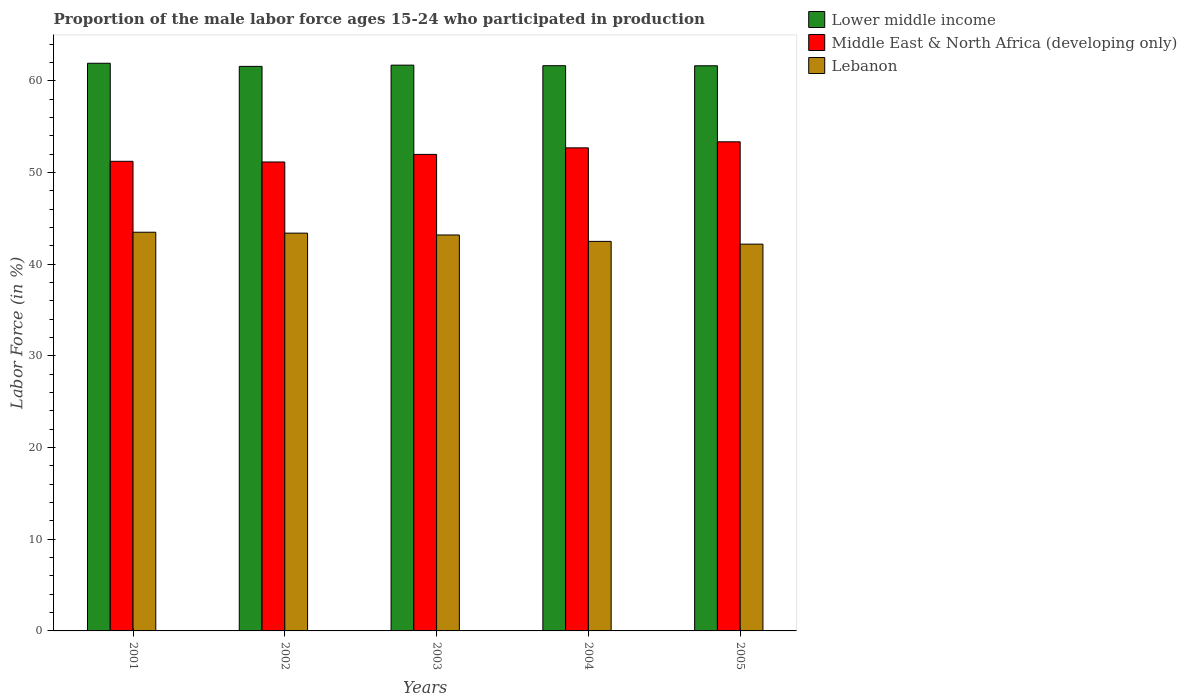Are the number of bars per tick equal to the number of legend labels?
Your response must be concise. Yes. Are the number of bars on each tick of the X-axis equal?
Your response must be concise. Yes. How many bars are there on the 2nd tick from the left?
Keep it short and to the point. 3. What is the proportion of the male labor force who participated in production in Middle East & North Africa (developing only) in 2002?
Offer a very short reply. 51.16. Across all years, what is the maximum proportion of the male labor force who participated in production in Lower middle income?
Give a very brief answer. 61.93. Across all years, what is the minimum proportion of the male labor force who participated in production in Lebanon?
Ensure brevity in your answer.  42.2. What is the total proportion of the male labor force who participated in production in Lower middle income in the graph?
Offer a terse response. 308.58. What is the difference between the proportion of the male labor force who participated in production in Lebanon in 2002 and that in 2003?
Offer a terse response. 0.2. What is the difference between the proportion of the male labor force who participated in production in Lower middle income in 2003 and the proportion of the male labor force who participated in production in Lebanon in 2002?
Provide a succinct answer. 18.33. What is the average proportion of the male labor force who participated in production in Lower middle income per year?
Your answer should be compact. 61.72. In the year 2001, what is the difference between the proportion of the male labor force who participated in production in Lebanon and proportion of the male labor force who participated in production in Middle East & North Africa (developing only)?
Keep it short and to the point. -7.74. In how many years, is the proportion of the male labor force who participated in production in Lower middle income greater than 34 %?
Your response must be concise. 5. What is the ratio of the proportion of the male labor force who participated in production in Lower middle income in 2003 to that in 2004?
Offer a very short reply. 1. Is the proportion of the male labor force who participated in production in Lower middle income in 2003 less than that in 2005?
Offer a very short reply. No. Is the difference between the proportion of the male labor force who participated in production in Lebanon in 2002 and 2005 greater than the difference between the proportion of the male labor force who participated in production in Middle East & North Africa (developing only) in 2002 and 2005?
Ensure brevity in your answer.  Yes. What is the difference between the highest and the second highest proportion of the male labor force who participated in production in Middle East & North Africa (developing only)?
Provide a short and direct response. 0.66. What is the difference between the highest and the lowest proportion of the male labor force who participated in production in Lower middle income?
Provide a succinct answer. 0.34. In how many years, is the proportion of the male labor force who participated in production in Lebanon greater than the average proportion of the male labor force who participated in production in Lebanon taken over all years?
Ensure brevity in your answer.  3. Is the sum of the proportion of the male labor force who participated in production in Lebanon in 2003 and 2004 greater than the maximum proportion of the male labor force who participated in production in Lower middle income across all years?
Offer a very short reply. Yes. What does the 3rd bar from the left in 2005 represents?
Provide a succinct answer. Lebanon. What does the 2nd bar from the right in 2003 represents?
Your answer should be compact. Middle East & North Africa (developing only). Is it the case that in every year, the sum of the proportion of the male labor force who participated in production in Lower middle income and proportion of the male labor force who participated in production in Lebanon is greater than the proportion of the male labor force who participated in production in Middle East & North Africa (developing only)?
Ensure brevity in your answer.  Yes. How many years are there in the graph?
Your answer should be very brief. 5. What is the difference between two consecutive major ticks on the Y-axis?
Make the answer very short. 10. Where does the legend appear in the graph?
Ensure brevity in your answer.  Top right. How many legend labels are there?
Make the answer very short. 3. What is the title of the graph?
Offer a very short reply. Proportion of the male labor force ages 15-24 who participated in production. What is the label or title of the X-axis?
Ensure brevity in your answer.  Years. What is the label or title of the Y-axis?
Your answer should be compact. Labor Force (in %). What is the Labor Force (in %) of Lower middle income in 2001?
Keep it short and to the point. 61.93. What is the Labor Force (in %) in Middle East & North Africa (developing only) in 2001?
Provide a short and direct response. 51.24. What is the Labor Force (in %) of Lebanon in 2001?
Provide a succinct answer. 43.5. What is the Labor Force (in %) of Lower middle income in 2002?
Your answer should be very brief. 61.59. What is the Labor Force (in %) in Middle East & North Africa (developing only) in 2002?
Offer a terse response. 51.16. What is the Labor Force (in %) in Lebanon in 2002?
Provide a succinct answer. 43.4. What is the Labor Force (in %) of Lower middle income in 2003?
Keep it short and to the point. 61.73. What is the Labor Force (in %) in Middle East & North Africa (developing only) in 2003?
Offer a very short reply. 51.99. What is the Labor Force (in %) in Lebanon in 2003?
Your answer should be very brief. 43.2. What is the Labor Force (in %) of Lower middle income in 2004?
Keep it short and to the point. 61.67. What is the Labor Force (in %) of Middle East & North Africa (developing only) in 2004?
Provide a succinct answer. 52.71. What is the Labor Force (in %) of Lebanon in 2004?
Make the answer very short. 42.5. What is the Labor Force (in %) in Lower middle income in 2005?
Ensure brevity in your answer.  61.66. What is the Labor Force (in %) of Middle East & North Africa (developing only) in 2005?
Your answer should be compact. 53.37. What is the Labor Force (in %) of Lebanon in 2005?
Your answer should be compact. 42.2. Across all years, what is the maximum Labor Force (in %) of Lower middle income?
Provide a succinct answer. 61.93. Across all years, what is the maximum Labor Force (in %) of Middle East & North Africa (developing only)?
Make the answer very short. 53.37. Across all years, what is the maximum Labor Force (in %) in Lebanon?
Offer a terse response. 43.5. Across all years, what is the minimum Labor Force (in %) in Lower middle income?
Your answer should be very brief. 61.59. Across all years, what is the minimum Labor Force (in %) of Middle East & North Africa (developing only)?
Keep it short and to the point. 51.16. Across all years, what is the minimum Labor Force (in %) in Lebanon?
Your answer should be compact. 42.2. What is the total Labor Force (in %) of Lower middle income in the graph?
Give a very brief answer. 308.58. What is the total Labor Force (in %) of Middle East & North Africa (developing only) in the graph?
Your answer should be very brief. 260.46. What is the total Labor Force (in %) in Lebanon in the graph?
Provide a short and direct response. 214.8. What is the difference between the Labor Force (in %) in Lower middle income in 2001 and that in 2002?
Provide a short and direct response. 0.34. What is the difference between the Labor Force (in %) of Middle East & North Africa (developing only) in 2001 and that in 2002?
Provide a short and direct response. 0.07. What is the difference between the Labor Force (in %) of Lebanon in 2001 and that in 2002?
Keep it short and to the point. 0.1. What is the difference between the Labor Force (in %) in Lower middle income in 2001 and that in 2003?
Give a very brief answer. 0.21. What is the difference between the Labor Force (in %) in Middle East & North Africa (developing only) in 2001 and that in 2003?
Keep it short and to the point. -0.75. What is the difference between the Labor Force (in %) of Lebanon in 2001 and that in 2003?
Your answer should be very brief. 0.3. What is the difference between the Labor Force (in %) of Lower middle income in 2001 and that in 2004?
Offer a very short reply. 0.27. What is the difference between the Labor Force (in %) of Middle East & North Africa (developing only) in 2001 and that in 2004?
Keep it short and to the point. -1.47. What is the difference between the Labor Force (in %) of Lower middle income in 2001 and that in 2005?
Provide a succinct answer. 0.27. What is the difference between the Labor Force (in %) in Middle East & North Africa (developing only) in 2001 and that in 2005?
Your answer should be compact. -2.13. What is the difference between the Labor Force (in %) in Lower middle income in 2002 and that in 2003?
Keep it short and to the point. -0.13. What is the difference between the Labor Force (in %) in Middle East & North Africa (developing only) in 2002 and that in 2003?
Your response must be concise. -0.83. What is the difference between the Labor Force (in %) in Lebanon in 2002 and that in 2003?
Offer a very short reply. 0.2. What is the difference between the Labor Force (in %) of Lower middle income in 2002 and that in 2004?
Make the answer very short. -0.07. What is the difference between the Labor Force (in %) of Middle East & North Africa (developing only) in 2002 and that in 2004?
Ensure brevity in your answer.  -1.54. What is the difference between the Labor Force (in %) of Lebanon in 2002 and that in 2004?
Your answer should be compact. 0.9. What is the difference between the Labor Force (in %) of Lower middle income in 2002 and that in 2005?
Your answer should be very brief. -0.07. What is the difference between the Labor Force (in %) of Middle East & North Africa (developing only) in 2002 and that in 2005?
Offer a very short reply. -2.2. What is the difference between the Labor Force (in %) of Lebanon in 2002 and that in 2005?
Provide a succinct answer. 1.2. What is the difference between the Labor Force (in %) of Lower middle income in 2003 and that in 2004?
Offer a very short reply. 0.06. What is the difference between the Labor Force (in %) in Middle East & North Africa (developing only) in 2003 and that in 2004?
Make the answer very short. -0.72. What is the difference between the Labor Force (in %) in Lebanon in 2003 and that in 2004?
Make the answer very short. 0.7. What is the difference between the Labor Force (in %) in Lower middle income in 2003 and that in 2005?
Provide a short and direct response. 0.07. What is the difference between the Labor Force (in %) in Middle East & North Africa (developing only) in 2003 and that in 2005?
Make the answer very short. -1.37. What is the difference between the Labor Force (in %) of Lebanon in 2003 and that in 2005?
Your answer should be very brief. 1. What is the difference between the Labor Force (in %) in Lower middle income in 2004 and that in 2005?
Make the answer very short. 0.01. What is the difference between the Labor Force (in %) in Middle East & North Africa (developing only) in 2004 and that in 2005?
Your response must be concise. -0.66. What is the difference between the Labor Force (in %) of Lower middle income in 2001 and the Labor Force (in %) of Middle East & North Africa (developing only) in 2002?
Ensure brevity in your answer.  10.77. What is the difference between the Labor Force (in %) of Lower middle income in 2001 and the Labor Force (in %) of Lebanon in 2002?
Your answer should be compact. 18.53. What is the difference between the Labor Force (in %) in Middle East & North Africa (developing only) in 2001 and the Labor Force (in %) in Lebanon in 2002?
Ensure brevity in your answer.  7.84. What is the difference between the Labor Force (in %) in Lower middle income in 2001 and the Labor Force (in %) in Middle East & North Africa (developing only) in 2003?
Ensure brevity in your answer.  9.94. What is the difference between the Labor Force (in %) of Lower middle income in 2001 and the Labor Force (in %) of Lebanon in 2003?
Ensure brevity in your answer.  18.73. What is the difference between the Labor Force (in %) in Middle East & North Africa (developing only) in 2001 and the Labor Force (in %) in Lebanon in 2003?
Ensure brevity in your answer.  8.04. What is the difference between the Labor Force (in %) in Lower middle income in 2001 and the Labor Force (in %) in Middle East & North Africa (developing only) in 2004?
Your answer should be compact. 9.23. What is the difference between the Labor Force (in %) in Lower middle income in 2001 and the Labor Force (in %) in Lebanon in 2004?
Your answer should be very brief. 19.43. What is the difference between the Labor Force (in %) in Middle East & North Africa (developing only) in 2001 and the Labor Force (in %) in Lebanon in 2004?
Your answer should be very brief. 8.74. What is the difference between the Labor Force (in %) of Lower middle income in 2001 and the Labor Force (in %) of Middle East & North Africa (developing only) in 2005?
Your answer should be very brief. 8.57. What is the difference between the Labor Force (in %) of Lower middle income in 2001 and the Labor Force (in %) of Lebanon in 2005?
Make the answer very short. 19.73. What is the difference between the Labor Force (in %) in Middle East & North Africa (developing only) in 2001 and the Labor Force (in %) in Lebanon in 2005?
Your response must be concise. 9.04. What is the difference between the Labor Force (in %) of Lower middle income in 2002 and the Labor Force (in %) of Middle East & North Africa (developing only) in 2003?
Provide a succinct answer. 9.6. What is the difference between the Labor Force (in %) in Lower middle income in 2002 and the Labor Force (in %) in Lebanon in 2003?
Your answer should be very brief. 18.39. What is the difference between the Labor Force (in %) in Middle East & North Africa (developing only) in 2002 and the Labor Force (in %) in Lebanon in 2003?
Give a very brief answer. 7.96. What is the difference between the Labor Force (in %) of Lower middle income in 2002 and the Labor Force (in %) of Middle East & North Africa (developing only) in 2004?
Your answer should be very brief. 8.89. What is the difference between the Labor Force (in %) in Lower middle income in 2002 and the Labor Force (in %) in Lebanon in 2004?
Your answer should be compact. 19.09. What is the difference between the Labor Force (in %) in Middle East & North Africa (developing only) in 2002 and the Labor Force (in %) in Lebanon in 2004?
Your response must be concise. 8.66. What is the difference between the Labor Force (in %) in Lower middle income in 2002 and the Labor Force (in %) in Middle East & North Africa (developing only) in 2005?
Keep it short and to the point. 8.23. What is the difference between the Labor Force (in %) of Lower middle income in 2002 and the Labor Force (in %) of Lebanon in 2005?
Ensure brevity in your answer.  19.39. What is the difference between the Labor Force (in %) in Middle East & North Africa (developing only) in 2002 and the Labor Force (in %) in Lebanon in 2005?
Offer a terse response. 8.96. What is the difference between the Labor Force (in %) of Lower middle income in 2003 and the Labor Force (in %) of Middle East & North Africa (developing only) in 2004?
Your response must be concise. 9.02. What is the difference between the Labor Force (in %) of Lower middle income in 2003 and the Labor Force (in %) of Lebanon in 2004?
Offer a very short reply. 19.23. What is the difference between the Labor Force (in %) of Middle East & North Africa (developing only) in 2003 and the Labor Force (in %) of Lebanon in 2004?
Make the answer very short. 9.49. What is the difference between the Labor Force (in %) of Lower middle income in 2003 and the Labor Force (in %) of Middle East & North Africa (developing only) in 2005?
Your answer should be compact. 8.36. What is the difference between the Labor Force (in %) of Lower middle income in 2003 and the Labor Force (in %) of Lebanon in 2005?
Provide a short and direct response. 19.53. What is the difference between the Labor Force (in %) in Middle East & North Africa (developing only) in 2003 and the Labor Force (in %) in Lebanon in 2005?
Your response must be concise. 9.79. What is the difference between the Labor Force (in %) of Lower middle income in 2004 and the Labor Force (in %) of Middle East & North Africa (developing only) in 2005?
Offer a terse response. 8.3. What is the difference between the Labor Force (in %) of Lower middle income in 2004 and the Labor Force (in %) of Lebanon in 2005?
Your answer should be very brief. 19.47. What is the difference between the Labor Force (in %) in Middle East & North Africa (developing only) in 2004 and the Labor Force (in %) in Lebanon in 2005?
Keep it short and to the point. 10.51. What is the average Labor Force (in %) in Lower middle income per year?
Your answer should be very brief. 61.72. What is the average Labor Force (in %) of Middle East & North Africa (developing only) per year?
Give a very brief answer. 52.09. What is the average Labor Force (in %) in Lebanon per year?
Give a very brief answer. 42.96. In the year 2001, what is the difference between the Labor Force (in %) in Lower middle income and Labor Force (in %) in Middle East & North Africa (developing only)?
Offer a terse response. 10.7. In the year 2001, what is the difference between the Labor Force (in %) of Lower middle income and Labor Force (in %) of Lebanon?
Provide a short and direct response. 18.43. In the year 2001, what is the difference between the Labor Force (in %) of Middle East & North Africa (developing only) and Labor Force (in %) of Lebanon?
Make the answer very short. 7.74. In the year 2002, what is the difference between the Labor Force (in %) in Lower middle income and Labor Force (in %) in Middle East & North Africa (developing only)?
Give a very brief answer. 10.43. In the year 2002, what is the difference between the Labor Force (in %) of Lower middle income and Labor Force (in %) of Lebanon?
Provide a succinct answer. 18.19. In the year 2002, what is the difference between the Labor Force (in %) in Middle East & North Africa (developing only) and Labor Force (in %) in Lebanon?
Keep it short and to the point. 7.76. In the year 2003, what is the difference between the Labor Force (in %) of Lower middle income and Labor Force (in %) of Middle East & North Africa (developing only)?
Make the answer very short. 9.74. In the year 2003, what is the difference between the Labor Force (in %) in Lower middle income and Labor Force (in %) in Lebanon?
Your answer should be compact. 18.53. In the year 2003, what is the difference between the Labor Force (in %) in Middle East & North Africa (developing only) and Labor Force (in %) in Lebanon?
Your response must be concise. 8.79. In the year 2004, what is the difference between the Labor Force (in %) in Lower middle income and Labor Force (in %) in Middle East & North Africa (developing only)?
Keep it short and to the point. 8.96. In the year 2004, what is the difference between the Labor Force (in %) of Lower middle income and Labor Force (in %) of Lebanon?
Offer a very short reply. 19.17. In the year 2004, what is the difference between the Labor Force (in %) in Middle East & North Africa (developing only) and Labor Force (in %) in Lebanon?
Your answer should be very brief. 10.21. In the year 2005, what is the difference between the Labor Force (in %) of Lower middle income and Labor Force (in %) of Middle East & North Africa (developing only)?
Your answer should be very brief. 8.3. In the year 2005, what is the difference between the Labor Force (in %) of Lower middle income and Labor Force (in %) of Lebanon?
Offer a terse response. 19.46. In the year 2005, what is the difference between the Labor Force (in %) of Middle East & North Africa (developing only) and Labor Force (in %) of Lebanon?
Make the answer very short. 11.17. What is the ratio of the Labor Force (in %) of Lower middle income in 2001 to that in 2002?
Provide a succinct answer. 1.01. What is the ratio of the Labor Force (in %) in Lower middle income in 2001 to that in 2003?
Offer a very short reply. 1. What is the ratio of the Labor Force (in %) in Middle East & North Africa (developing only) in 2001 to that in 2003?
Your response must be concise. 0.99. What is the ratio of the Labor Force (in %) in Middle East & North Africa (developing only) in 2001 to that in 2004?
Your answer should be very brief. 0.97. What is the ratio of the Labor Force (in %) of Lebanon in 2001 to that in 2004?
Give a very brief answer. 1.02. What is the ratio of the Labor Force (in %) in Lower middle income in 2001 to that in 2005?
Your answer should be compact. 1. What is the ratio of the Labor Force (in %) in Middle East & North Africa (developing only) in 2001 to that in 2005?
Your answer should be compact. 0.96. What is the ratio of the Labor Force (in %) of Lebanon in 2001 to that in 2005?
Keep it short and to the point. 1.03. What is the ratio of the Labor Force (in %) in Middle East & North Africa (developing only) in 2002 to that in 2003?
Keep it short and to the point. 0.98. What is the ratio of the Labor Force (in %) of Lower middle income in 2002 to that in 2004?
Provide a short and direct response. 1. What is the ratio of the Labor Force (in %) in Middle East & North Africa (developing only) in 2002 to that in 2004?
Your answer should be compact. 0.97. What is the ratio of the Labor Force (in %) in Lebanon in 2002 to that in 2004?
Make the answer very short. 1.02. What is the ratio of the Labor Force (in %) of Middle East & North Africa (developing only) in 2002 to that in 2005?
Your response must be concise. 0.96. What is the ratio of the Labor Force (in %) in Lebanon in 2002 to that in 2005?
Offer a very short reply. 1.03. What is the ratio of the Labor Force (in %) in Lower middle income in 2003 to that in 2004?
Offer a very short reply. 1. What is the ratio of the Labor Force (in %) in Middle East & North Africa (developing only) in 2003 to that in 2004?
Your response must be concise. 0.99. What is the ratio of the Labor Force (in %) of Lebanon in 2003 to that in 2004?
Your answer should be very brief. 1.02. What is the ratio of the Labor Force (in %) of Middle East & North Africa (developing only) in 2003 to that in 2005?
Your answer should be very brief. 0.97. What is the ratio of the Labor Force (in %) of Lebanon in 2003 to that in 2005?
Provide a succinct answer. 1.02. What is the ratio of the Labor Force (in %) in Middle East & North Africa (developing only) in 2004 to that in 2005?
Ensure brevity in your answer.  0.99. What is the ratio of the Labor Force (in %) in Lebanon in 2004 to that in 2005?
Offer a very short reply. 1.01. What is the difference between the highest and the second highest Labor Force (in %) in Lower middle income?
Provide a succinct answer. 0.21. What is the difference between the highest and the second highest Labor Force (in %) of Middle East & North Africa (developing only)?
Your response must be concise. 0.66. What is the difference between the highest and the second highest Labor Force (in %) of Lebanon?
Keep it short and to the point. 0.1. What is the difference between the highest and the lowest Labor Force (in %) of Lower middle income?
Your answer should be very brief. 0.34. What is the difference between the highest and the lowest Labor Force (in %) of Middle East & North Africa (developing only)?
Ensure brevity in your answer.  2.2. What is the difference between the highest and the lowest Labor Force (in %) in Lebanon?
Give a very brief answer. 1.3. 